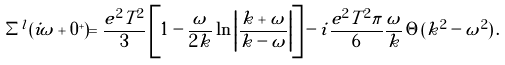Convert formula to latex. <formula><loc_0><loc_0><loc_500><loc_500>\Sigma ^ { l } ( i \omega + 0 ^ { + } ) = \frac { e ^ { 2 } T ^ { 2 } } { 3 } \left [ 1 - \frac { \omega } { 2 k } \ln \left | \frac { k + \omega } { k - \omega } \right | \right ] - i \frac { e ^ { 2 } T ^ { 2 } \pi } { 6 } \frac { \omega } { k } \, \Theta ( k ^ { 2 } - \omega ^ { 2 } ) \, .</formula> 